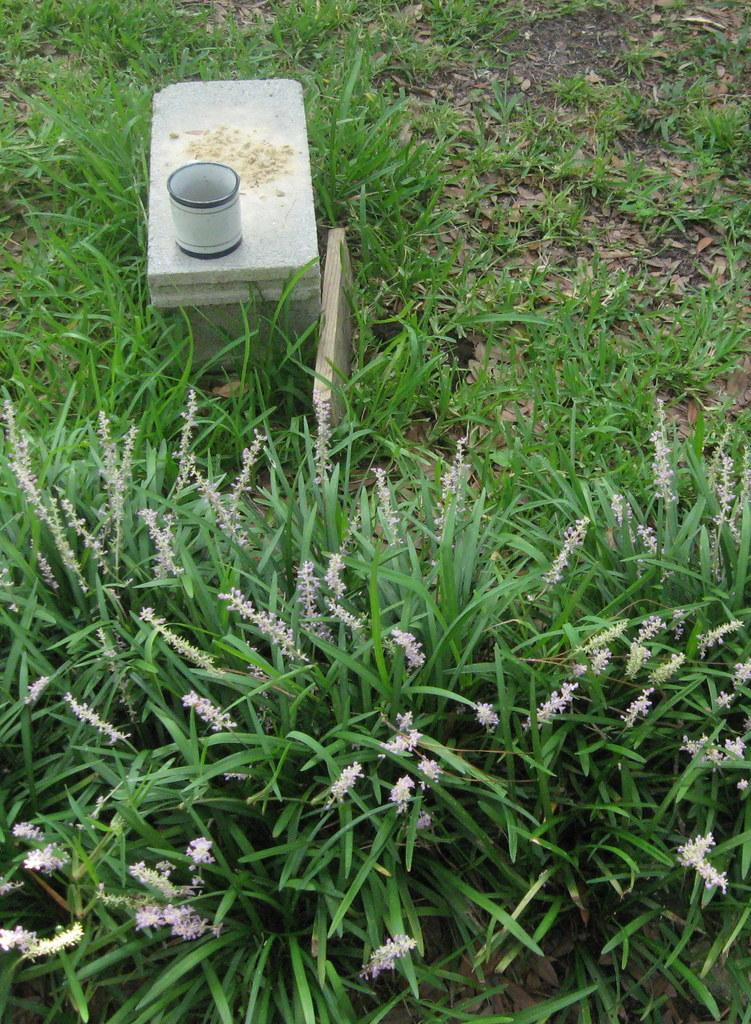What type of plants are at the bottom of the image? There are flower plants at the bottom of the image. What can be seen in the background of the image? There is a cement block in the background of the image. What is placed on the cement block? There is a cup on the cement block. What other plants are visible in the image? There are small plants on the ground in the image. What type of mouth can be seen on the ship in the image? There is no ship present in the image, so there is no mouth to observe. How many quarters are visible in the image? There is no mention of quarters in the provided facts, so it cannot be determined from the image. 